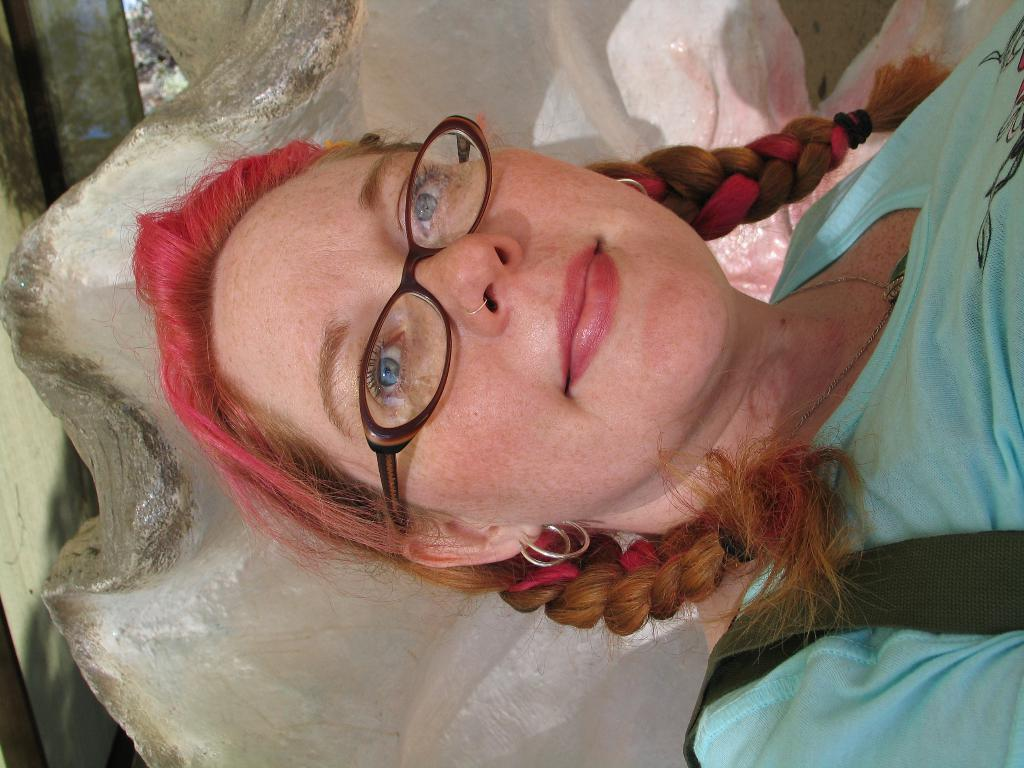Who is present in the image? There is a woman in the image. What is the woman wearing? The woman is wearing a blue T-shirt. What is the woman carrying in the image? The woman is carrying a bag. What can be seen in the background of the image? There is a structure in the background of the image. What type of cars can be seen in the image? There are no cars present in the image. What is the woman's primary source of pleasure in the image? The image does not provide information about the woman's source of pleasure. Is the woman playing a game of chess in the image? There is no indication of a chess game or any game in the image. 